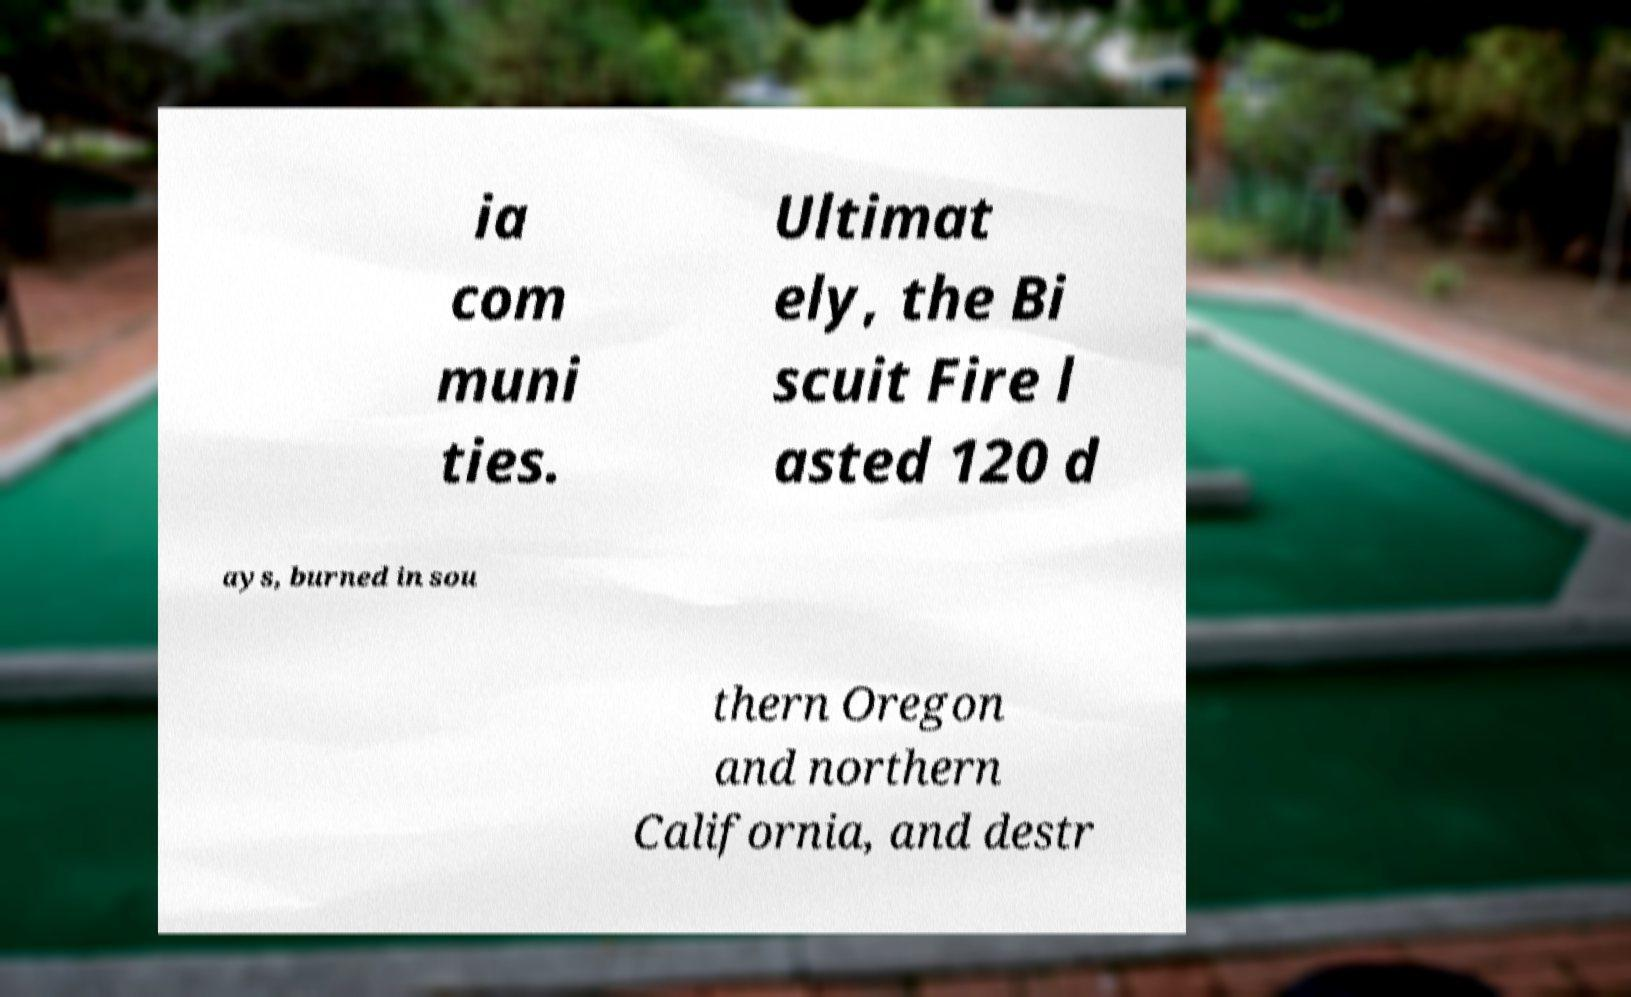I need the written content from this picture converted into text. Can you do that? ia com muni ties. Ultimat ely, the Bi scuit Fire l asted 120 d ays, burned in sou thern Oregon and northern California, and destr 